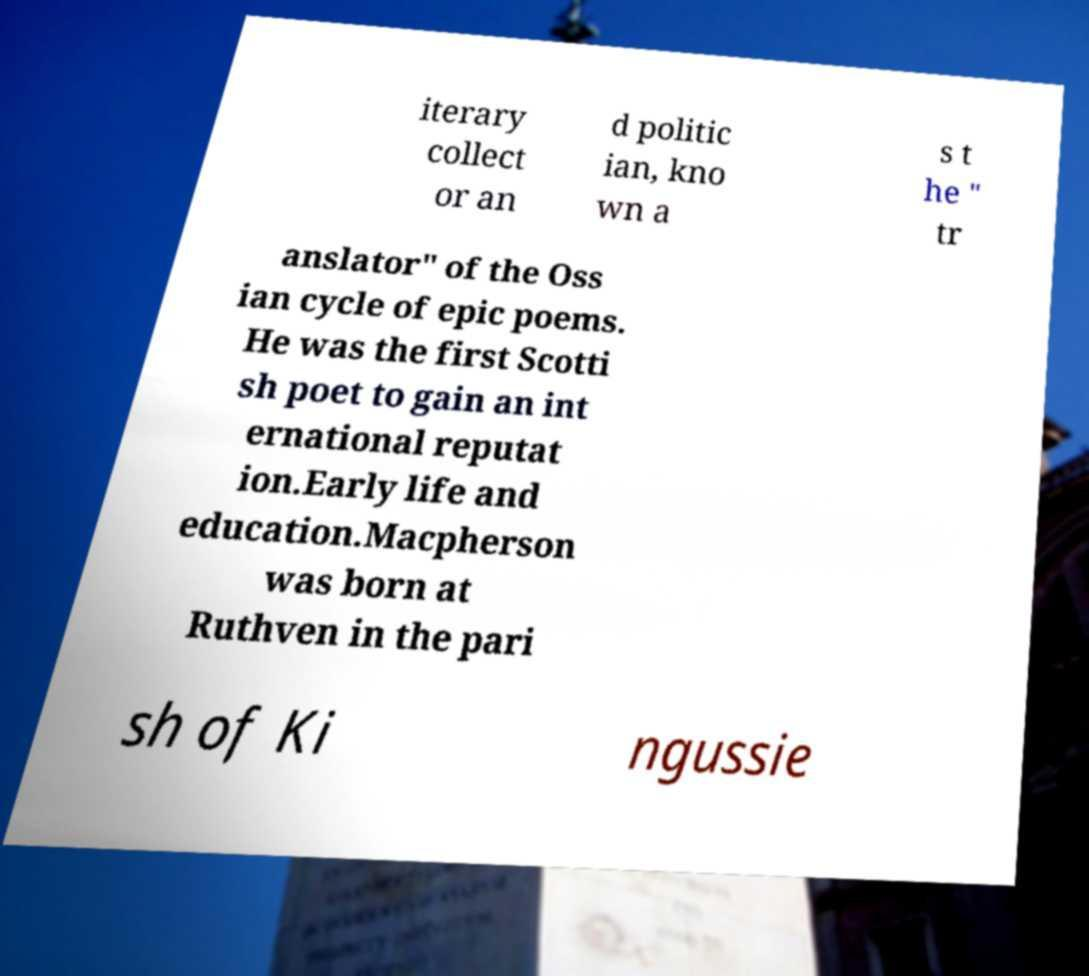I need the written content from this picture converted into text. Can you do that? iterary collect or an d politic ian, kno wn a s t he " tr anslator" of the Oss ian cycle of epic poems. He was the first Scotti sh poet to gain an int ernational reputat ion.Early life and education.Macpherson was born at Ruthven in the pari sh of Ki ngussie 